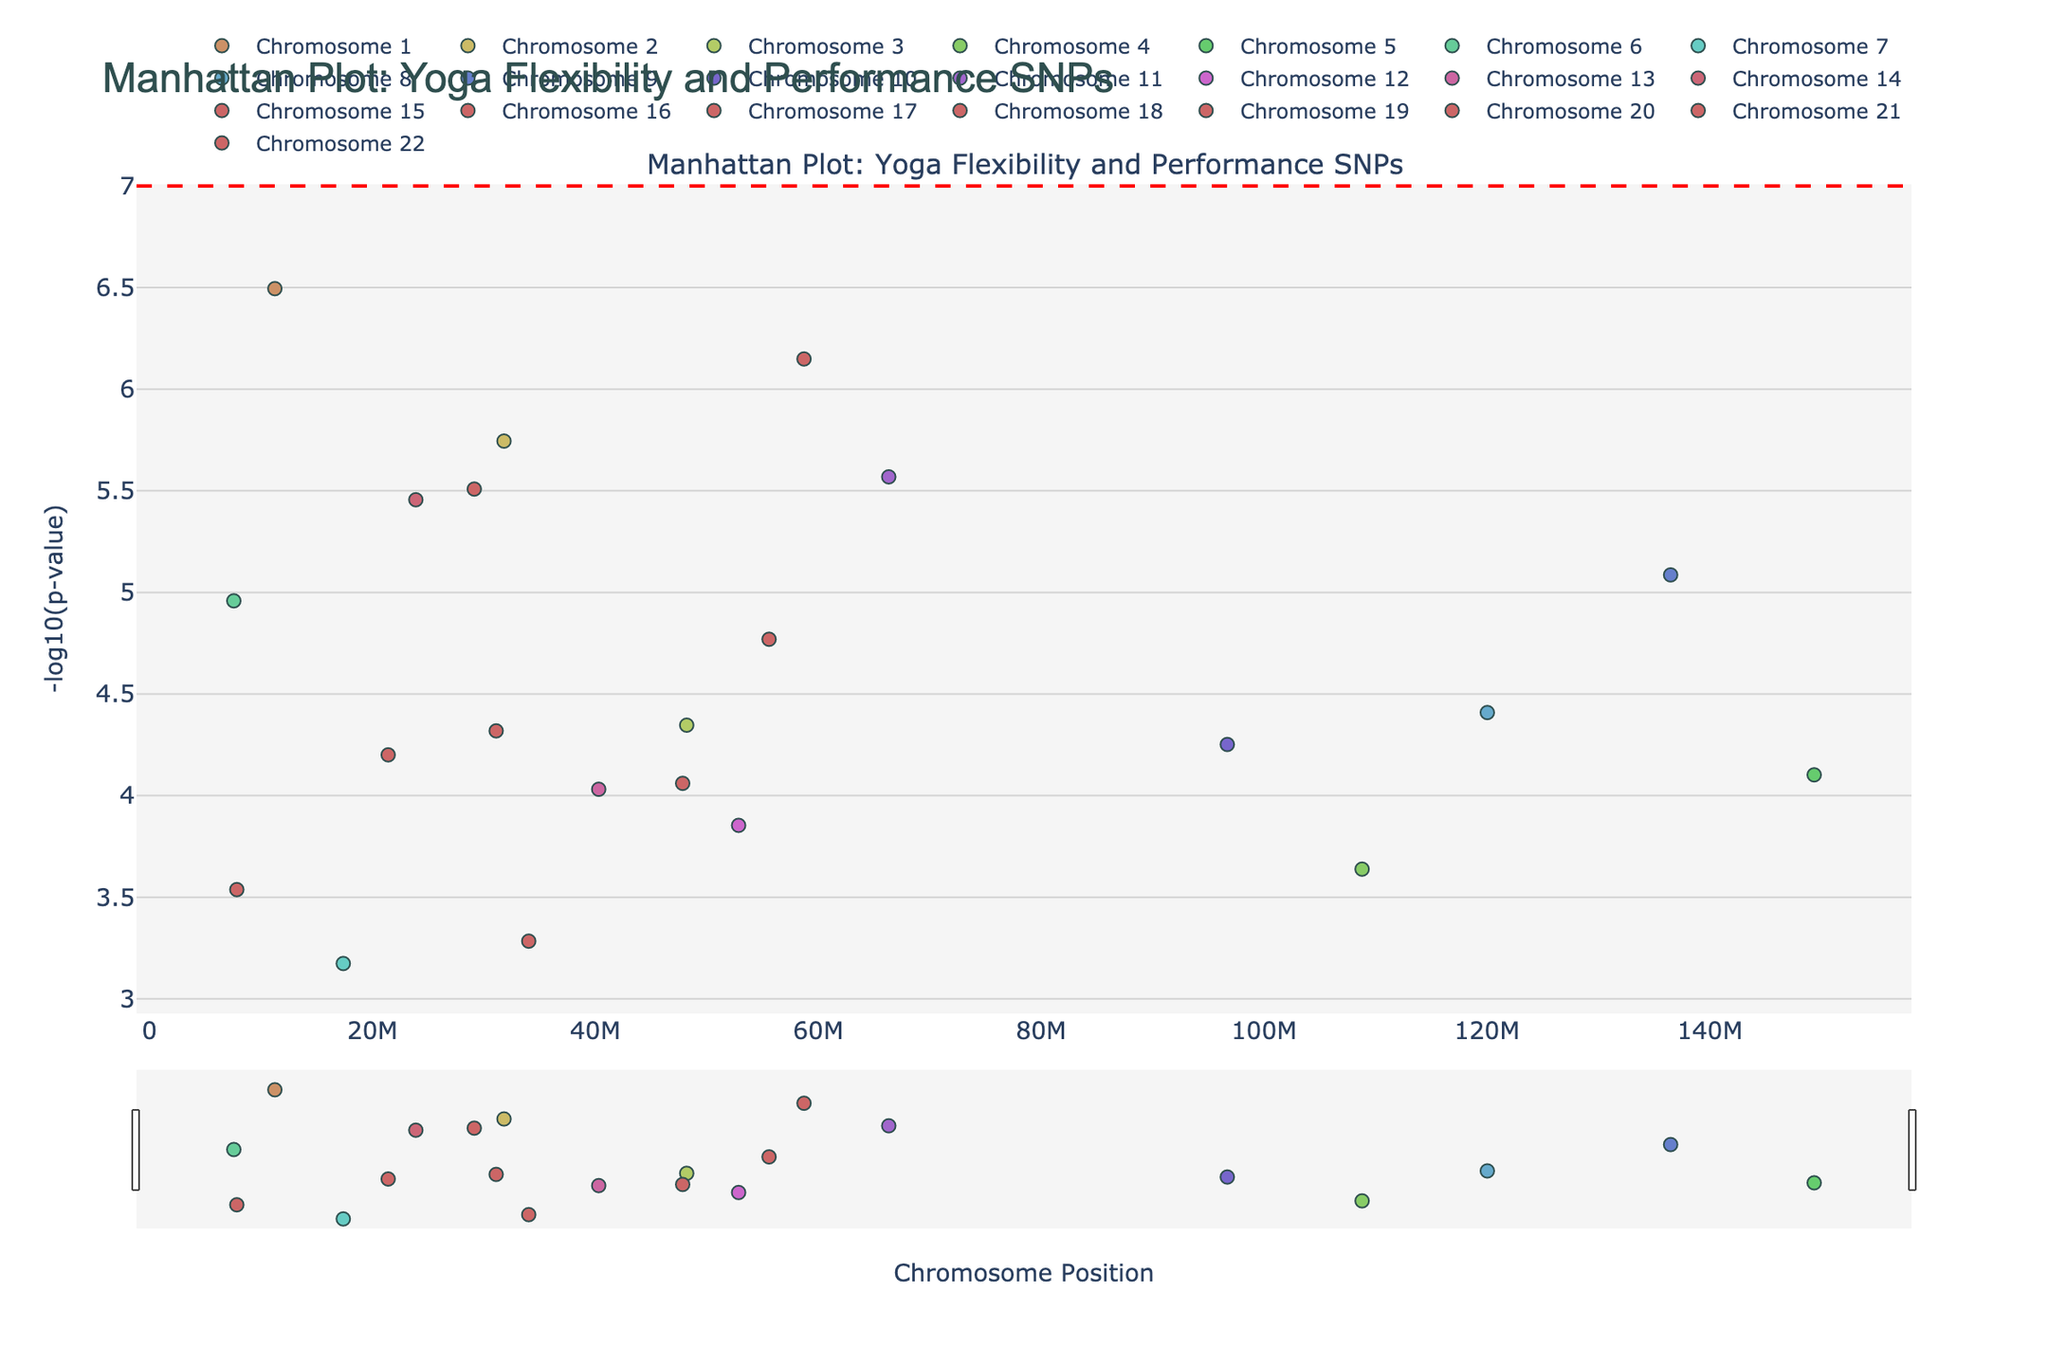What's the title of the plot? The title is displayed prominently at the top of the figure, often in a larger or bolder font compared to the rest of the text.
Answer: Manhattan Plot: Yoga Flexibility and Performance SNPs What is the y-axis labeled as? The y-axis label is typically found along the vertical axis of the figure, indicating the metric used.
Answer: -log10(p-value) Which chromosome has the SNP with the lowest p-value? To identify the chromosome with the lowest p-value SNP, find the data point with the highest -log10(p-value) on the y-axis, then check its corresponding chromosome.
Answer: Chromosome 1 How many SNPs have a -log10(p-value) greater than 5? Count the number of data points exceeding the y-axis value of 5. This value corresponds to -log10(p-value).
Answer: 8 Which SNP is associated with gene VDR, and what is its -log10(p-value) value? Find the SNP marker associated with the gene VDR and read its -log10(p-value).
Answer: rs2228570, 6.49 Compare the -log10(p-value) of SNPs on chromosome 6 and chromosome 11. Which has the higher value? Locate the data points for chromosomes 6 and 11, compare their y-axis values. The one with the higher value has a higher -log10(p-value).
Answer: Chromosome 11 What is the significance threshold indicated by the horizontal line, and why is it important? The horizontal line is drawn at -log10(5e-8) typically, used to indicate genome-wide significance in GWAS studies.
Answer: 7, important for identifying significant SNPs Which chromosome has the most significant gene associated with flexibility and performance? Determine the chromosome with the highest -log10(p-value) data point.
Answer: Chromosome 1 Which gene has the second-highest -log10(p-value) value and what chromosome is it located on? Identify the gene with the second-highest y-axis value and locate its corresponding chromosome.
Answer: PPARA, Chromosome 14 Compare the number of significant SNPs (above the threshold line) on chromosomes 1 and 15. Which has more? Count the significant SNPs above the horizontal threshold line for chromosomes 1 and 15 and compare the counts.
Answer: Chromosome 1 